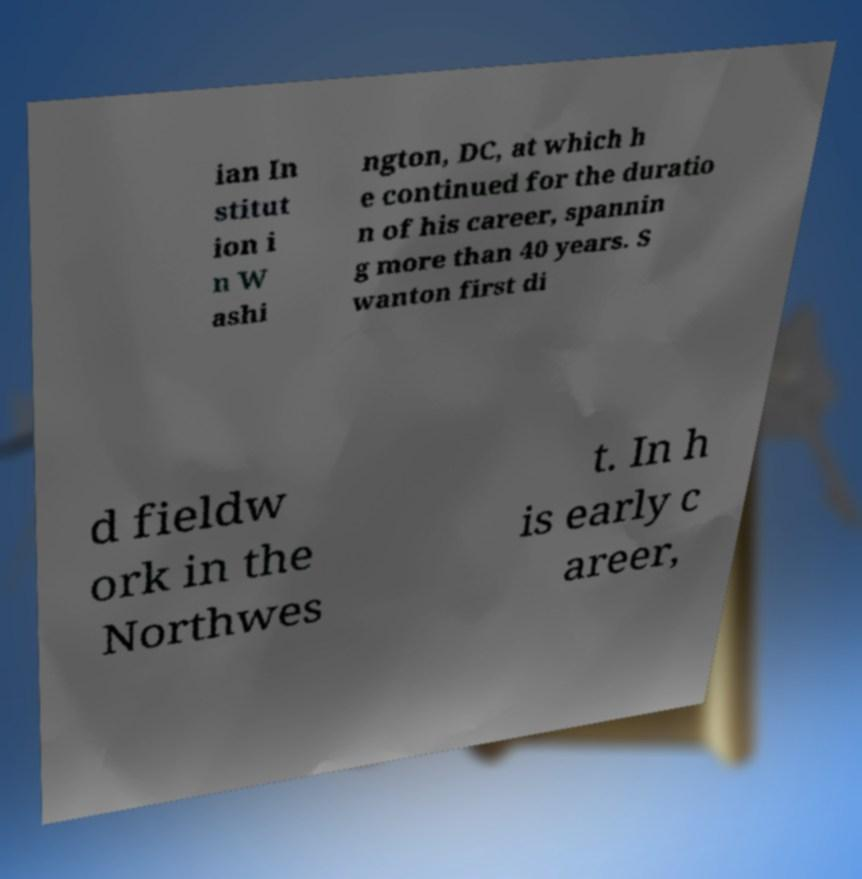Could you extract and type out the text from this image? ian In stitut ion i n W ashi ngton, DC, at which h e continued for the duratio n of his career, spannin g more than 40 years. S wanton first di d fieldw ork in the Northwes t. In h is early c areer, 